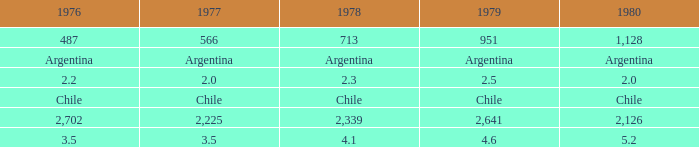What is 1980 when 1979 is 951? 1128.0. 